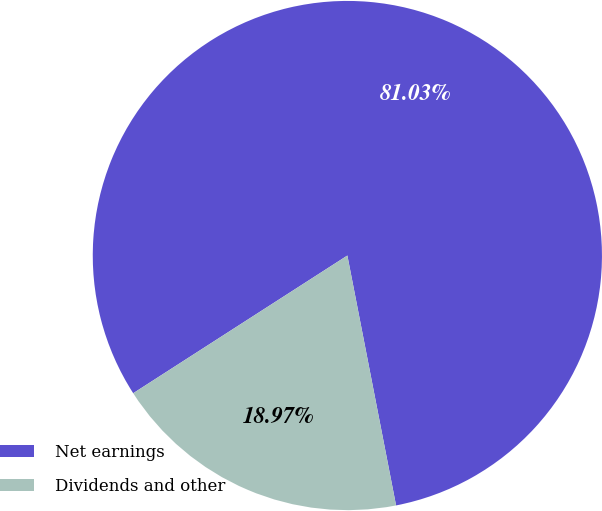Convert chart to OTSL. <chart><loc_0><loc_0><loc_500><loc_500><pie_chart><fcel>Net earnings<fcel>Dividends and other<nl><fcel>81.03%<fcel>18.97%<nl></chart> 